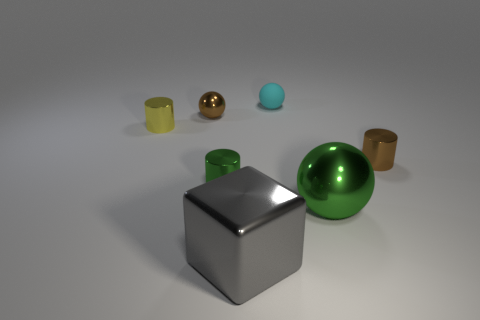How many other objects are there of the same shape as the large gray metallic thing?
Your answer should be compact. 0. What material is the tiny brown cylinder?
Your answer should be very brief. Metal. Is there anything else of the same color as the large metal cube?
Your answer should be compact. No. Is the small yellow object made of the same material as the big green ball?
Your response must be concise. Yes. How many things are to the left of the green metallic object that is right of the tiny rubber object that is to the right of the brown ball?
Keep it short and to the point. 5. What number of small brown metal blocks are there?
Keep it short and to the point. 0. Are there fewer large green metallic spheres that are on the left side of the tiny yellow metal object than tiny brown metallic things on the right side of the small cyan ball?
Offer a very short reply. Yes. Are there fewer tiny brown objects that are behind the tiny yellow metal object than tiny brown balls?
Give a very brief answer. No. What is the object that is on the right side of the metallic sphere in front of the small object that is right of the large ball made of?
Ensure brevity in your answer.  Metal. How many things are cylinders on the right side of the small green cylinder or small brown shiny objects to the right of the brown sphere?
Make the answer very short. 1. 